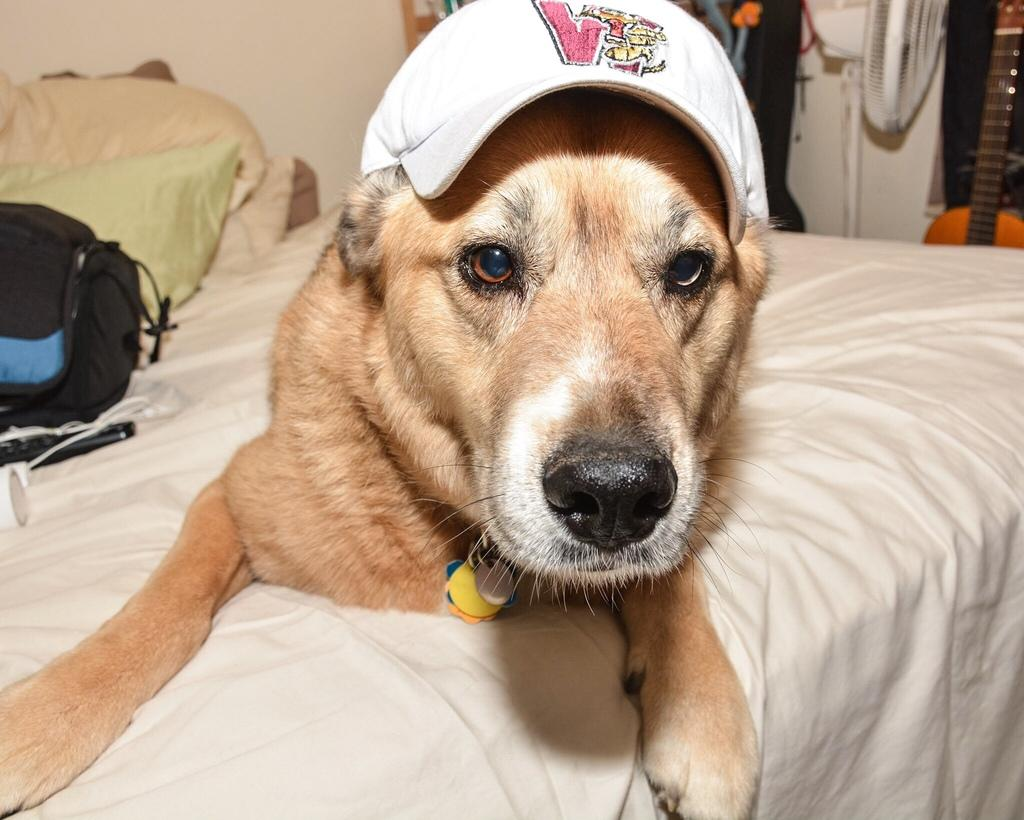What type of animal is in the image? There is a dog in the image. Where is the dog located? The dog is laying on the bed. What is the dog wearing? The dog is wearing a cap. What can be seen in the background of the image? There is a bag, objects, a table fan, a guitar, and a wall visible in the background. What time of day does the dog enjoy playing with the can in the image? There is no can present in the image, and the time of day is not mentioned or depicted. 